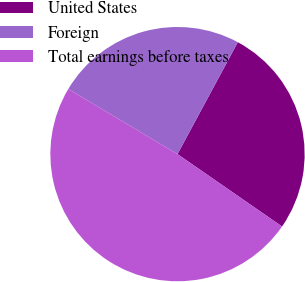Convert chart to OTSL. <chart><loc_0><loc_0><loc_500><loc_500><pie_chart><fcel>United States<fcel>Foreign<fcel>Total earnings before taxes<nl><fcel>26.77%<fcel>24.31%<fcel>48.92%<nl></chart> 